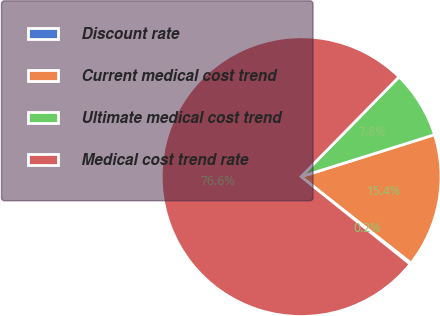<chart> <loc_0><loc_0><loc_500><loc_500><pie_chart><fcel>Discount rate<fcel>Current medical cost trend<fcel>Ultimate medical cost trend<fcel>Medical cost trend rate<nl><fcel>0.16%<fcel>15.45%<fcel>7.8%<fcel>76.59%<nl></chart> 